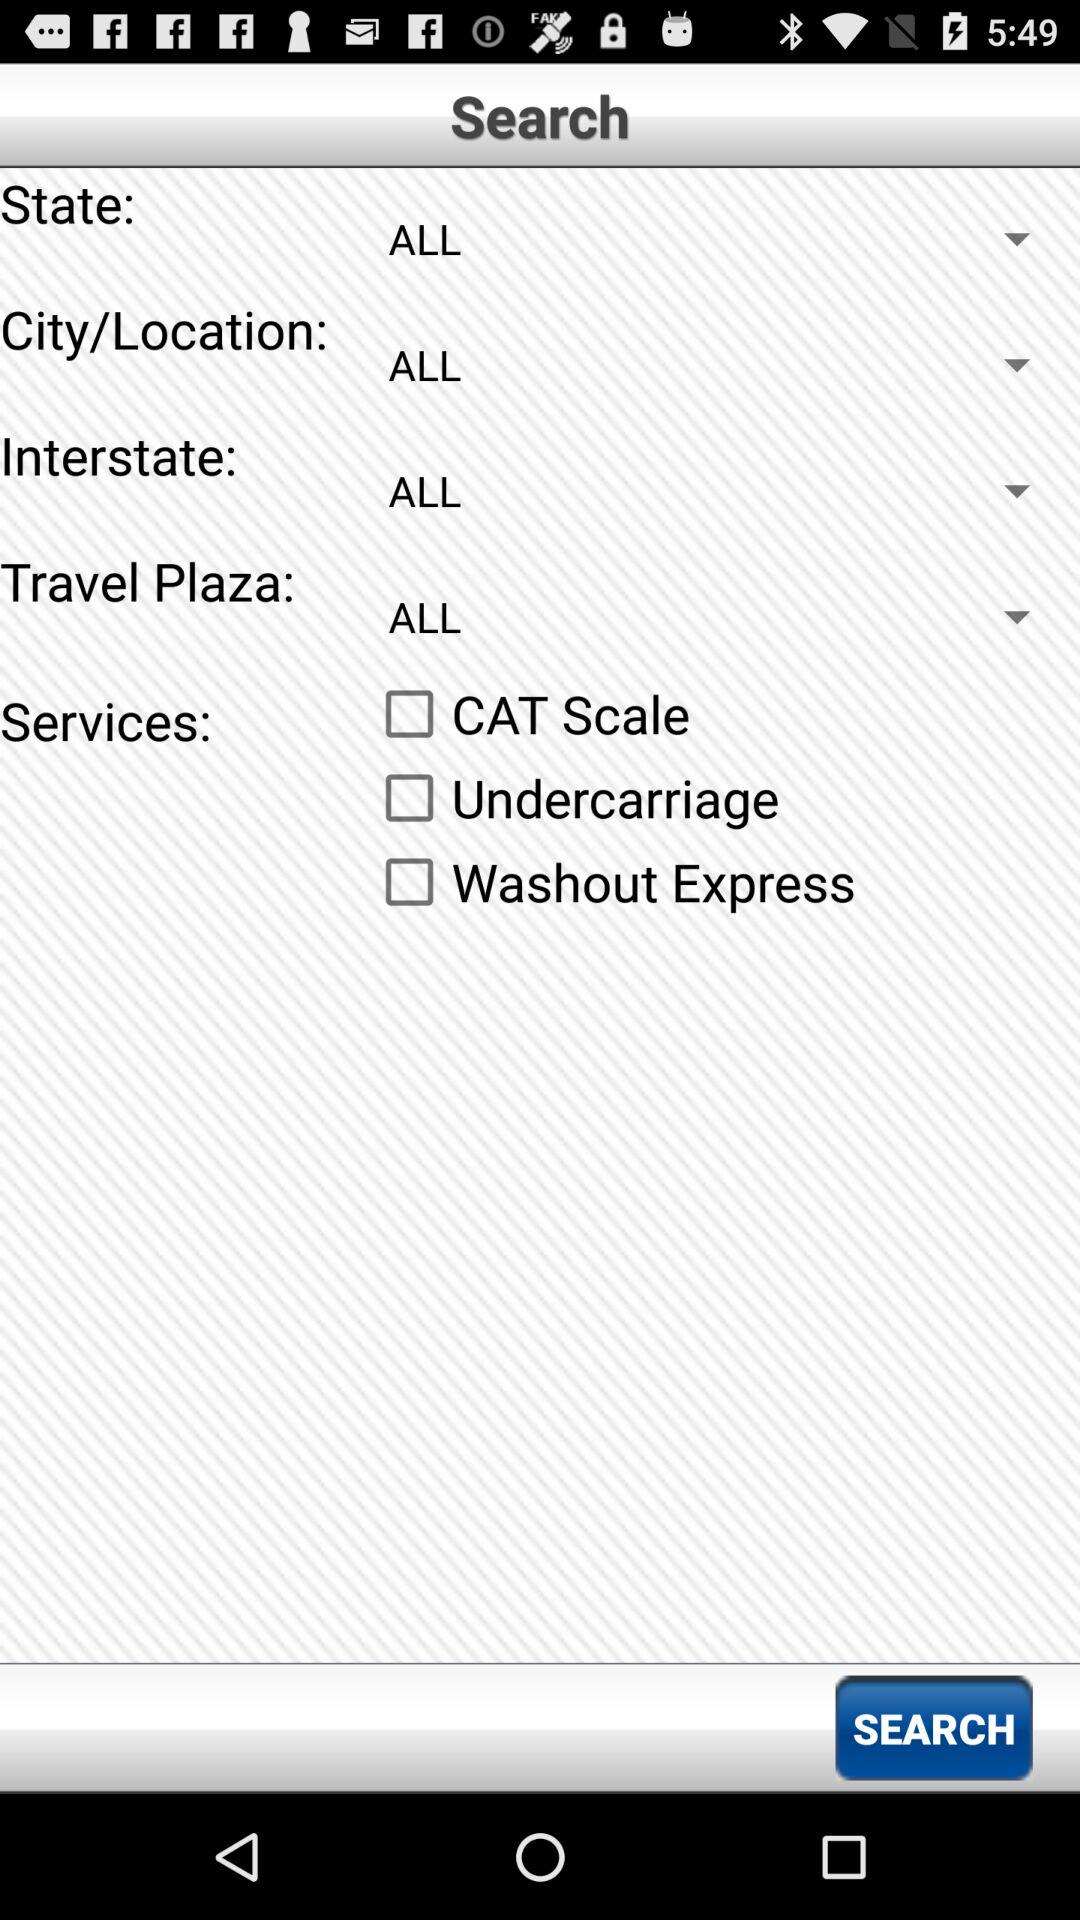Which location was selected? The selected location was "ALL". 